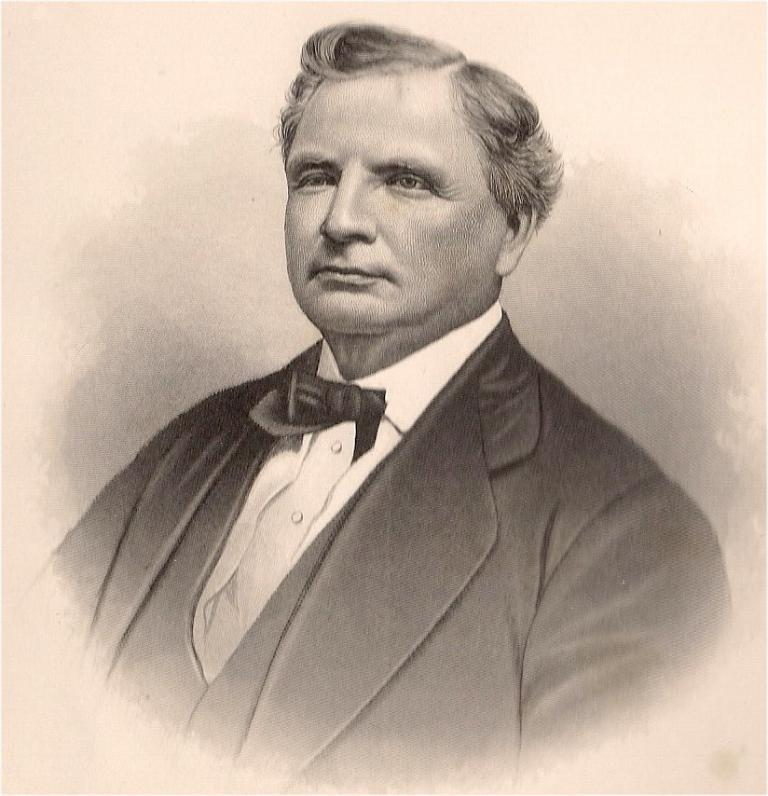What is the main subject of the image? There is a drawing in the image. What does the drawing depict? The drawing depicts a person. What is the person in the drawing wearing? The person in the drawing is wearing a suit. How many cabbages are visible in the drawing? There are no cabbages present in the drawing; it depicts a person wearing a suit. Is there any money visible in the drawing? There is no money visible in the drawing; it depicts a person wearing a suit. 